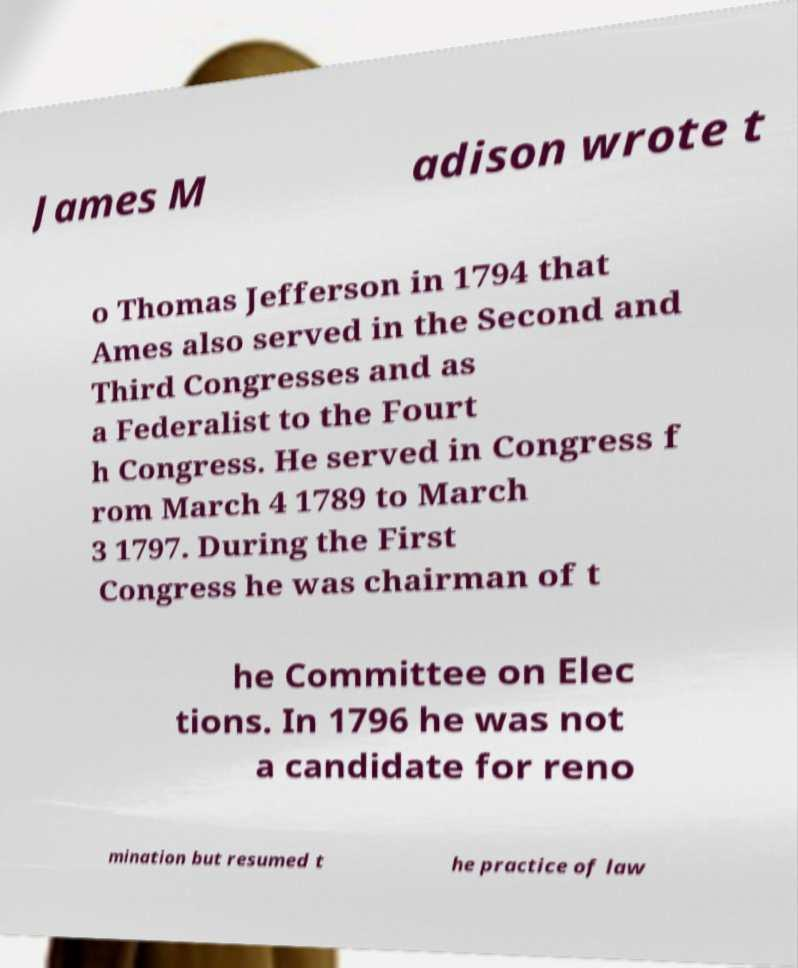Please identify and transcribe the text found in this image. James M adison wrote t o Thomas Jefferson in 1794 that Ames also served in the Second and Third Congresses and as a Federalist to the Fourt h Congress. He served in Congress f rom March 4 1789 to March 3 1797. During the First Congress he was chairman of t he Committee on Elec tions. In 1796 he was not a candidate for reno mination but resumed t he practice of law 